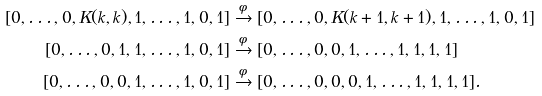Convert formula to latex. <formula><loc_0><loc_0><loc_500><loc_500>[ 0 , \dots , 0 , K ( k , k ) , 1 , \dots , 1 , 0 , 1 ] & \xrightarrow { \phi } [ 0 , \dots , 0 , K ( k + 1 , k + 1 ) , 1 , \dots , 1 , 0 , 1 ] \\ [ 0 , \dots , 0 , 1 , 1 , \dots , 1 , 0 , 1 ] & \xrightarrow { \phi } [ 0 , \dots , 0 , 0 , 1 , \dots , 1 , 1 , 1 , 1 ] \\ [ 0 , \dots , 0 , 0 , 1 , \dots , 1 , 0 , 1 ] & \xrightarrow { \phi } [ 0 , \dots , 0 , 0 , 0 , 1 , \dots , 1 , 1 , 1 , 1 ] .</formula> 